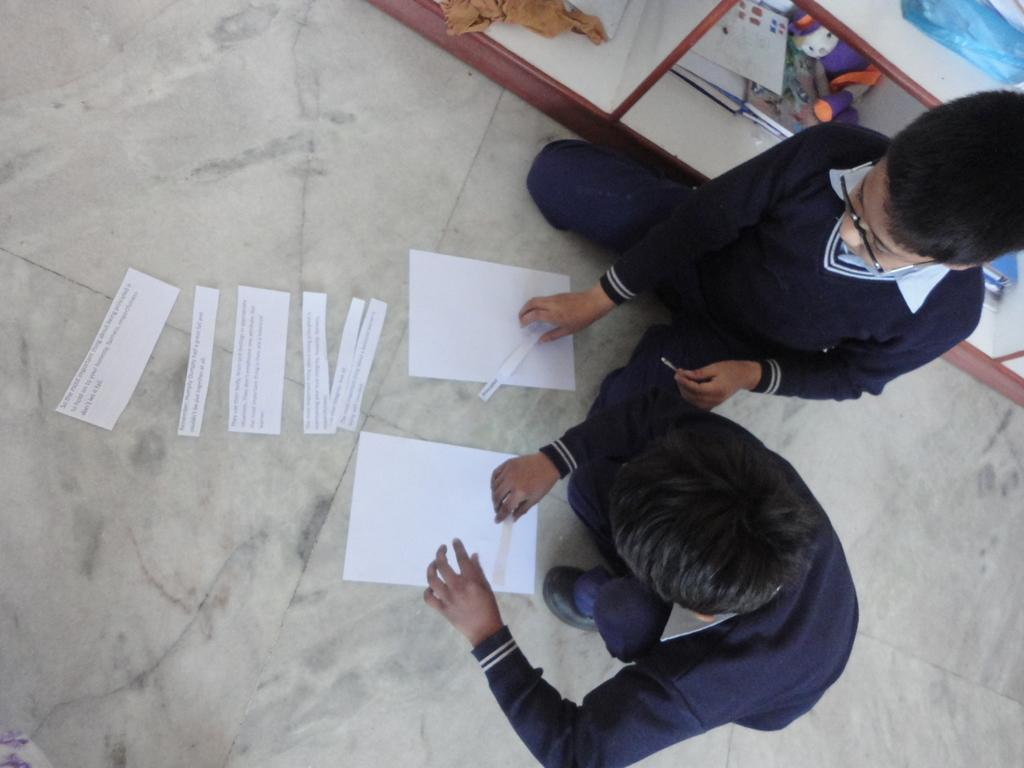How many boys are in the image? There are two boys in the image. What are the boys doing with the papers? The boys are touching papers in the image. What type of clothing are the boys wearing? The boys are wearing sweaters in the image. What can be seen on the right side of the image? There are books and other things on shelves on the right side of the image. What type of trousers are the boys wearing in the image? The provided facts do not mention the type of trousers the boys are wearing; only their sweaters are mentioned. What time of day is it in the image? The provided facts do not mention the time of day; there is no indication of morning or any other time. 